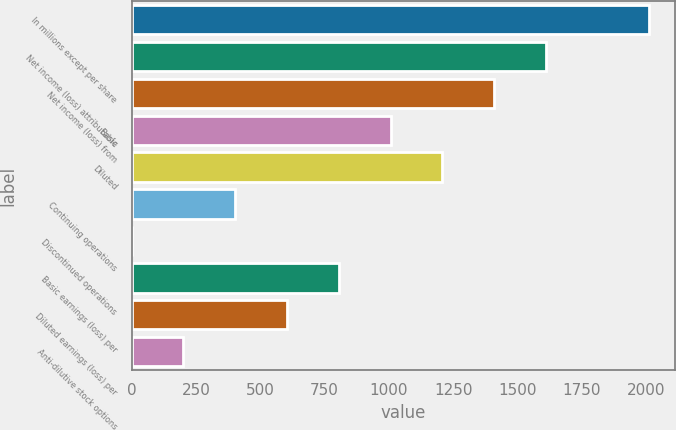Convert chart. <chart><loc_0><loc_0><loc_500><loc_500><bar_chart><fcel>In millions except per share<fcel>Net income (loss) attributable<fcel>Net income (loss) from<fcel>Basic<fcel>Diluted<fcel>Continuing operations<fcel>Discontinued operations<fcel>Basic earnings (loss) per<fcel>Diluted earnings (loss) per<fcel>Anti-dilutive stock options<nl><fcel>2013<fcel>1610.45<fcel>1409.16<fcel>1006.58<fcel>1207.87<fcel>402.71<fcel>0.13<fcel>805.29<fcel>604<fcel>201.42<nl></chart> 